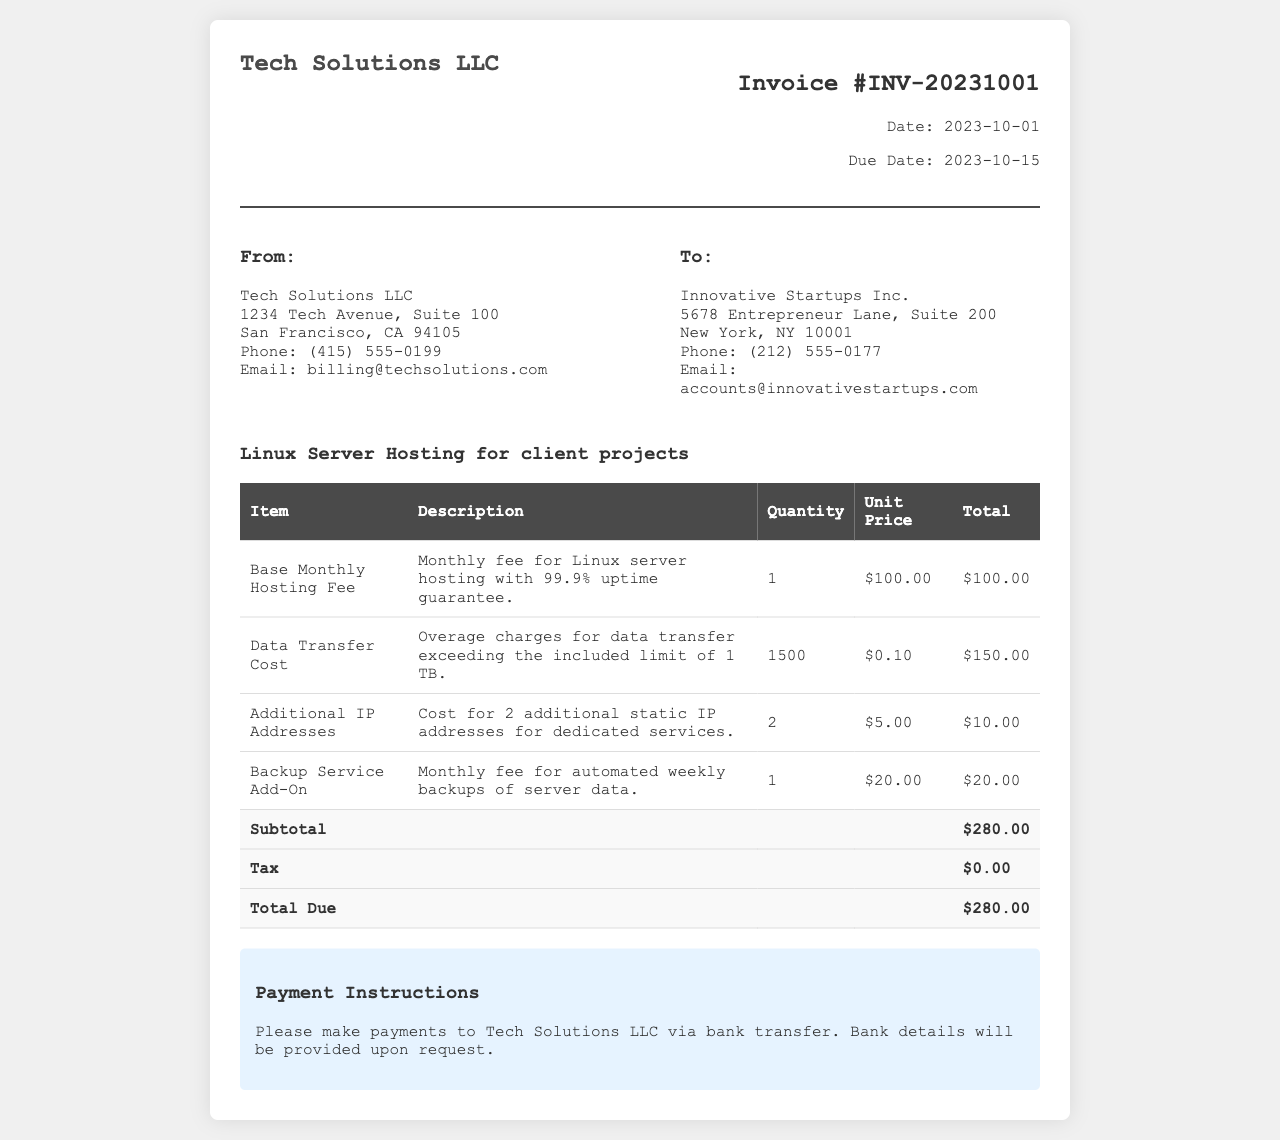What is the invoice number? The invoice number is located in the header section of the document, listed as INV-20231001.
Answer: INV-20231001 What is the due date for the invoice? The due date is found in the header section, detailing when the payment is expected, which is October 15, 2023.
Answer: 2023-10-15 What is the base monthly hosting fee? The base monthly hosting fee is listed in the table of charges, which states it is 100.00.
Answer: $100.00 How much is charged for data transfer overage? The table specifies the cost for exceeding the included data transfer limit, which is 0.10 per additional unit.
Answer: $0.10 What is the subtotal before tax? The subtotal is calculated from the total of all charges before adding tax, shown as 280.00 in the document.
Answer: $280.00 How many additional IP addresses are included? The item for additional IP addresses indicates a quantity of 2, which is the number of extra addresses requested.
Answer: 2 What service is provided for weekly backups? The document outlines a specific add-on for backup services, indicating that it is a weekly backup service.
Answer: Backup Service Add-On What payment method is suggested? The payment instructions mention a bank transfer as the preferred method for payment to Tech Solutions LLC.
Answer: Bank transfer What is the total amount due? The total amount due is listed at the bottom of the charges table, summing up all fees and taxes.
Answer: $280.00 